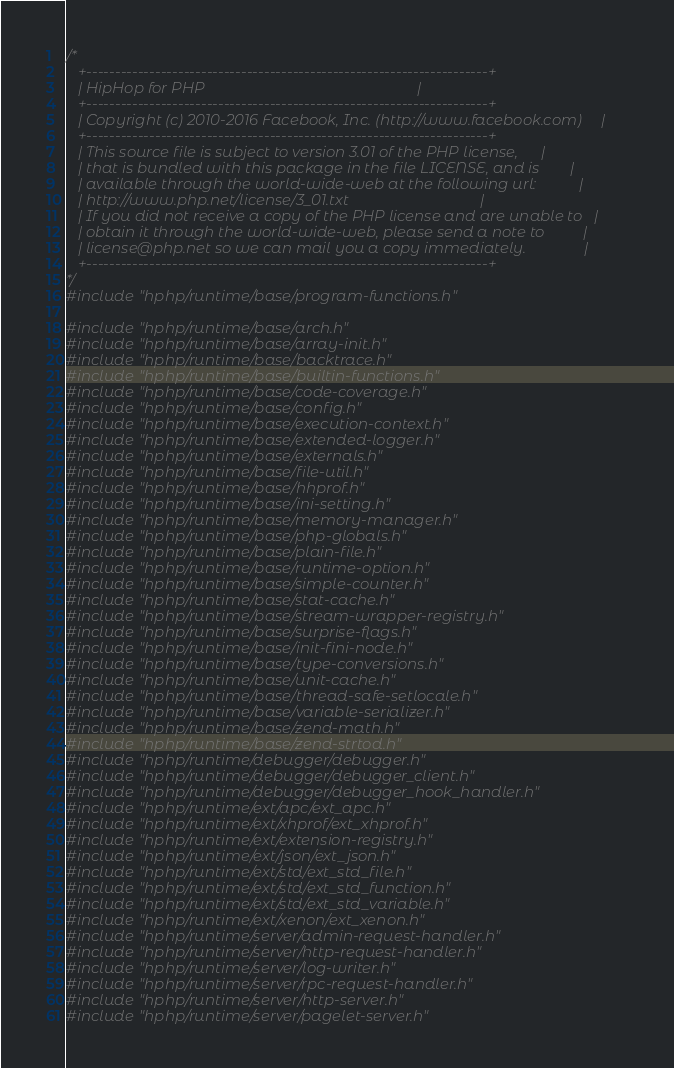<code> <loc_0><loc_0><loc_500><loc_500><_C++_>/*
   +----------------------------------------------------------------------+
   | HipHop for PHP                                                       |
   +----------------------------------------------------------------------+
   | Copyright (c) 2010-2016 Facebook, Inc. (http://www.facebook.com)     |
   +----------------------------------------------------------------------+
   | This source file is subject to version 3.01 of the PHP license,      |
   | that is bundled with this package in the file LICENSE, and is        |
   | available through the world-wide-web at the following url:           |
   | http://www.php.net/license/3_01.txt                                  |
   | If you did not receive a copy of the PHP license and are unable to   |
   | obtain it through the world-wide-web, please send a note to          |
   | license@php.net so we can mail you a copy immediately.               |
   +----------------------------------------------------------------------+
*/
#include "hphp/runtime/base/program-functions.h"

#include "hphp/runtime/base/arch.h"
#include "hphp/runtime/base/array-init.h"
#include "hphp/runtime/base/backtrace.h"
#include "hphp/runtime/base/builtin-functions.h"
#include "hphp/runtime/base/code-coverage.h"
#include "hphp/runtime/base/config.h"
#include "hphp/runtime/base/execution-context.h"
#include "hphp/runtime/base/extended-logger.h"
#include "hphp/runtime/base/externals.h"
#include "hphp/runtime/base/file-util.h"
#include "hphp/runtime/base/hhprof.h"
#include "hphp/runtime/base/ini-setting.h"
#include "hphp/runtime/base/memory-manager.h"
#include "hphp/runtime/base/php-globals.h"
#include "hphp/runtime/base/plain-file.h"
#include "hphp/runtime/base/runtime-option.h"
#include "hphp/runtime/base/simple-counter.h"
#include "hphp/runtime/base/stat-cache.h"
#include "hphp/runtime/base/stream-wrapper-registry.h"
#include "hphp/runtime/base/surprise-flags.h"
#include "hphp/runtime/base/init-fini-node.h"
#include "hphp/runtime/base/type-conversions.h"
#include "hphp/runtime/base/unit-cache.h"
#include "hphp/runtime/base/thread-safe-setlocale.h"
#include "hphp/runtime/base/variable-serializer.h"
#include "hphp/runtime/base/zend-math.h"
#include "hphp/runtime/base/zend-strtod.h"
#include "hphp/runtime/debugger/debugger.h"
#include "hphp/runtime/debugger/debugger_client.h"
#include "hphp/runtime/debugger/debugger_hook_handler.h"
#include "hphp/runtime/ext/apc/ext_apc.h"
#include "hphp/runtime/ext/xhprof/ext_xhprof.h"
#include "hphp/runtime/ext/extension-registry.h"
#include "hphp/runtime/ext/json/ext_json.h"
#include "hphp/runtime/ext/std/ext_std_file.h"
#include "hphp/runtime/ext/std/ext_std_function.h"
#include "hphp/runtime/ext/std/ext_std_variable.h"
#include "hphp/runtime/ext/xenon/ext_xenon.h"
#include "hphp/runtime/server/admin-request-handler.h"
#include "hphp/runtime/server/http-request-handler.h"
#include "hphp/runtime/server/log-writer.h"
#include "hphp/runtime/server/rpc-request-handler.h"
#include "hphp/runtime/server/http-server.h"
#include "hphp/runtime/server/pagelet-server.h"</code> 